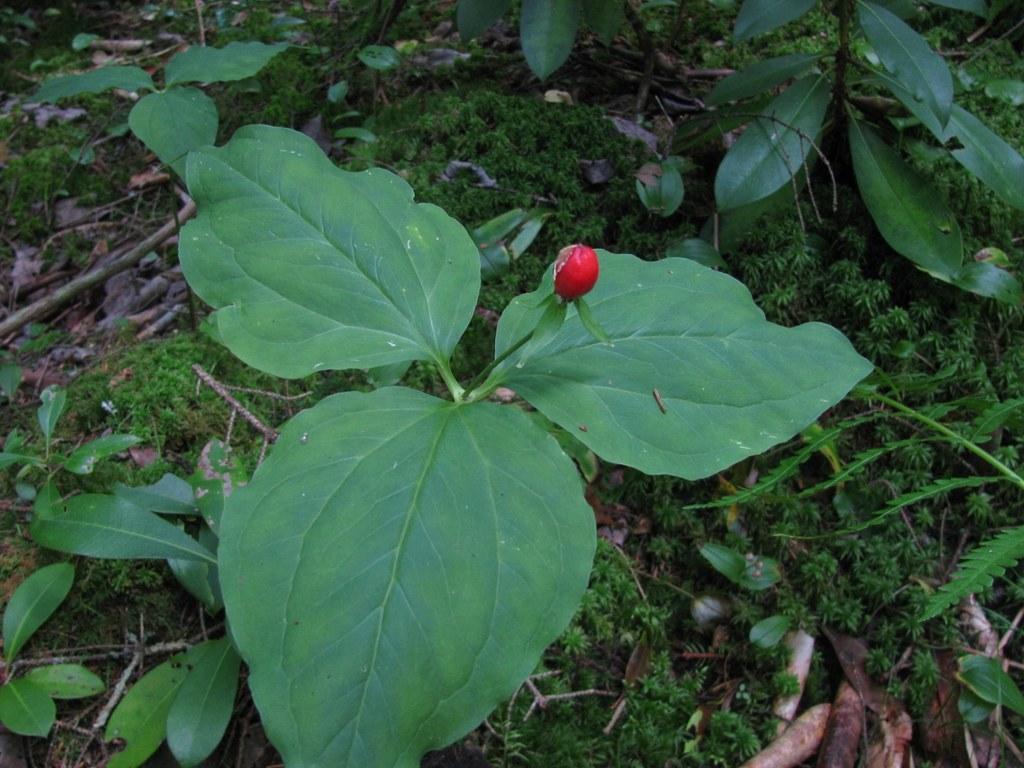How would you summarize this image in a sentence or two? There is a red color bud to a plant, there is greenery, dry stems and leaves around the area. 